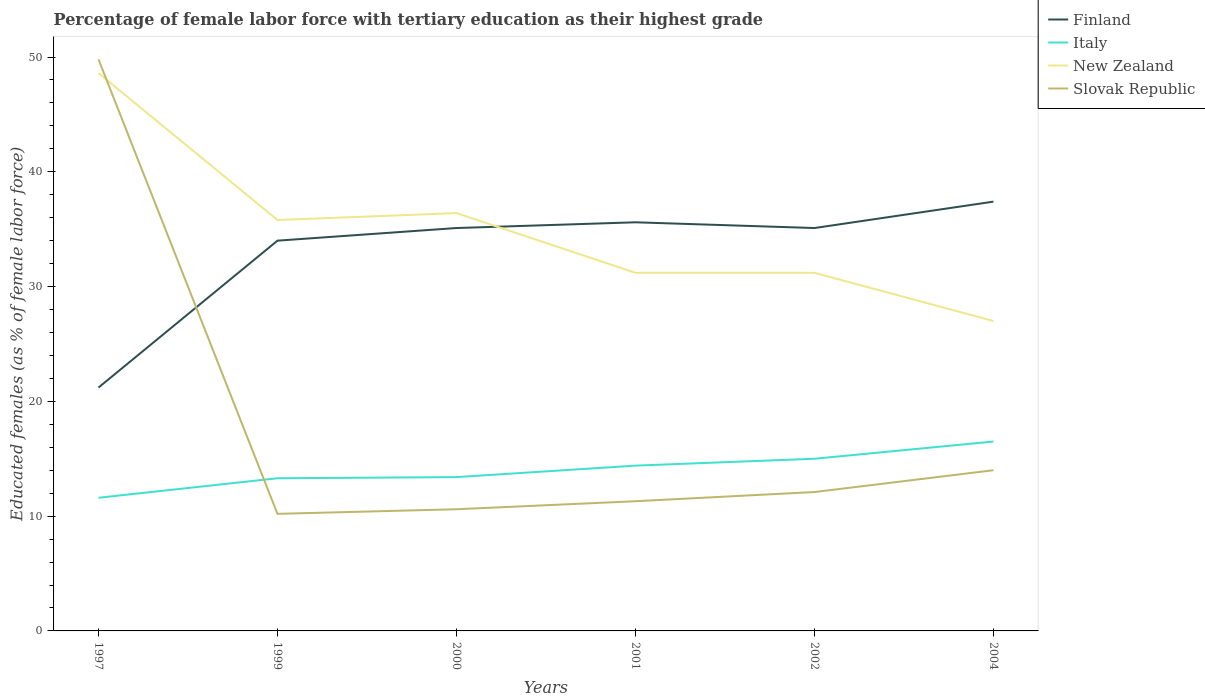Is the number of lines equal to the number of legend labels?
Ensure brevity in your answer.  Yes. What is the total percentage of female labor force with tertiary education in Italy in the graph?
Your answer should be very brief. -2.8. What is the difference between the highest and the second highest percentage of female labor force with tertiary education in New Zealand?
Provide a succinct answer. 21.6. Is the percentage of female labor force with tertiary education in New Zealand strictly greater than the percentage of female labor force with tertiary education in Finland over the years?
Provide a succinct answer. No. Are the values on the major ticks of Y-axis written in scientific E-notation?
Your answer should be very brief. No. Does the graph contain any zero values?
Provide a succinct answer. No. Does the graph contain grids?
Make the answer very short. No. What is the title of the graph?
Offer a terse response. Percentage of female labor force with tertiary education as their highest grade. What is the label or title of the Y-axis?
Your response must be concise. Educated females (as % of female labor force). What is the Educated females (as % of female labor force) in Finland in 1997?
Offer a terse response. 21.2. What is the Educated females (as % of female labor force) in Italy in 1997?
Provide a succinct answer. 11.6. What is the Educated females (as % of female labor force) in New Zealand in 1997?
Your response must be concise. 48.6. What is the Educated females (as % of female labor force) in Slovak Republic in 1997?
Make the answer very short. 49.8. What is the Educated females (as % of female labor force) in Finland in 1999?
Ensure brevity in your answer.  34. What is the Educated females (as % of female labor force) of Italy in 1999?
Give a very brief answer. 13.3. What is the Educated females (as % of female labor force) in New Zealand in 1999?
Offer a terse response. 35.8. What is the Educated females (as % of female labor force) in Slovak Republic in 1999?
Offer a very short reply. 10.2. What is the Educated females (as % of female labor force) of Finland in 2000?
Provide a short and direct response. 35.1. What is the Educated females (as % of female labor force) of Italy in 2000?
Keep it short and to the point. 13.4. What is the Educated females (as % of female labor force) of New Zealand in 2000?
Keep it short and to the point. 36.4. What is the Educated females (as % of female labor force) of Slovak Republic in 2000?
Your answer should be compact. 10.6. What is the Educated females (as % of female labor force) of Finland in 2001?
Offer a very short reply. 35.6. What is the Educated females (as % of female labor force) in Italy in 2001?
Make the answer very short. 14.4. What is the Educated females (as % of female labor force) in New Zealand in 2001?
Keep it short and to the point. 31.2. What is the Educated females (as % of female labor force) of Slovak Republic in 2001?
Your answer should be very brief. 11.3. What is the Educated females (as % of female labor force) in Finland in 2002?
Ensure brevity in your answer.  35.1. What is the Educated females (as % of female labor force) in New Zealand in 2002?
Give a very brief answer. 31.2. What is the Educated females (as % of female labor force) in Slovak Republic in 2002?
Offer a terse response. 12.1. What is the Educated females (as % of female labor force) of Finland in 2004?
Your answer should be compact. 37.4. What is the Educated females (as % of female labor force) of Italy in 2004?
Your answer should be compact. 16.5. What is the Educated females (as % of female labor force) of Slovak Republic in 2004?
Give a very brief answer. 14. Across all years, what is the maximum Educated females (as % of female labor force) of Finland?
Offer a terse response. 37.4. Across all years, what is the maximum Educated females (as % of female labor force) of Italy?
Your answer should be very brief. 16.5. Across all years, what is the maximum Educated females (as % of female labor force) of New Zealand?
Your answer should be very brief. 48.6. Across all years, what is the maximum Educated females (as % of female labor force) of Slovak Republic?
Give a very brief answer. 49.8. Across all years, what is the minimum Educated females (as % of female labor force) of Finland?
Provide a short and direct response. 21.2. Across all years, what is the minimum Educated females (as % of female labor force) of Italy?
Offer a very short reply. 11.6. Across all years, what is the minimum Educated females (as % of female labor force) in Slovak Republic?
Give a very brief answer. 10.2. What is the total Educated females (as % of female labor force) in Finland in the graph?
Offer a terse response. 198.4. What is the total Educated females (as % of female labor force) in Italy in the graph?
Give a very brief answer. 84.2. What is the total Educated females (as % of female labor force) in New Zealand in the graph?
Offer a very short reply. 210.2. What is the total Educated females (as % of female labor force) in Slovak Republic in the graph?
Your answer should be very brief. 108. What is the difference between the Educated females (as % of female labor force) in New Zealand in 1997 and that in 1999?
Ensure brevity in your answer.  12.8. What is the difference between the Educated females (as % of female labor force) in Slovak Republic in 1997 and that in 1999?
Offer a very short reply. 39.6. What is the difference between the Educated females (as % of female labor force) of Finland in 1997 and that in 2000?
Your response must be concise. -13.9. What is the difference between the Educated females (as % of female labor force) of Italy in 1997 and that in 2000?
Provide a succinct answer. -1.8. What is the difference between the Educated females (as % of female labor force) of Slovak Republic in 1997 and that in 2000?
Offer a terse response. 39.2. What is the difference between the Educated females (as % of female labor force) in Finland in 1997 and that in 2001?
Your answer should be very brief. -14.4. What is the difference between the Educated females (as % of female labor force) in Slovak Republic in 1997 and that in 2001?
Your response must be concise. 38.5. What is the difference between the Educated females (as % of female labor force) of Italy in 1997 and that in 2002?
Your response must be concise. -3.4. What is the difference between the Educated females (as % of female labor force) in New Zealand in 1997 and that in 2002?
Provide a succinct answer. 17.4. What is the difference between the Educated females (as % of female labor force) of Slovak Republic in 1997 and that in 2002?
Provide a short and direct response. 37.7. What is the difference between the Educated females (as % of female labor force) in Finland in 1997 and that in 2004?
Provide a short and direct response. -16.2. What is the difference between the Educated females (as % of female labor force) of New Zealand in 1997 and that in 2004?
Offer a very short reply. 21.6. What is the difference between the Educated females (as % of female labor force) of Slovak Republic in 1997 and that in 2004?
Give a very brief answer. 35.8. What is the difference between the Educated females (as % of female labor force) in Slovak Republic in 1999 and that in 2000?
Your answer should be very brief. -0.4. What is the difference between the Educated females (as % of female labor force) of New Zealand in 1999 and that in 2001?
Your response must be concise. 4.6. What is the difference between the Educated females (as % of female labor force) in Slovak Republic in 1999 and that in 2001?
Your answer should be compact. -1.1. What is the difference between the Educated females (as % of female labor force) in Finland in 1999 and that in 2002?
Ensure brevity in your answer.  -1.1. What is the difference between the Educated females (as % of female labor force) of Italy in 1999 and that in 2004?
Provide a short and direct response. -3.2. What is the difference between the Educated females (as % of female labor force) in Slovak Republic in 1999 and that in 2004?
Your answer should be very brief. -3.8. What is the difference between the Educated females (as % of female labor force) of Finland in 2000 and that in 2001?
Your answer should be very brief. -0.5. What is the difference between the Educated females (as % of female labor force) of New Zealand in 2000 and that in 2001?
Your answer should be very brief. 5.2. What is the difference between the Educated females (as % of female labor force) of Slovak Republic in 2000 and that in 2001?
Provide a short and direct response. -0.7. What is the difference between the Educated females (as % of female labor force) in Slovak Republic in 2000 and that in 2004?
Offer a terse response. -3.4. What is the difference between the Educated females (as % of female labor force) in Finland in 2001 and that in 2002?
Your answer should be compact. 0.5. What is the difference between the Educated females (as % of female labor force) in New Zealand in 2001 and that in 2002?
Your answer should be compact. 0. What is the difference between the Educated females (as % of female labor force) in Italy in 2001 and that in 2004?
Your answer should be very brief. -2.1. What is the difference between the Educated females (as % of female labor force) of New Zealand in 2001 and that in 2004?
Offer a terse response. 4.2. What is the difference between the Educated females (as % of female labor force) in Slovak Republic in 2001 and that in 2004?
Give a very brief answer. -2.7. What is the difference between the Educated females (as % of female labor force) in Finland in 2002 and that in 2004?
Provide a succinct answer. -2.3. What is the difference between the Educated females (as % of female labor force) of New Zealand in 2002 and that in 2004?
Provide a succinct answer. 4.2. What is the difference between the Educated females (as % of female labor force) in Slovak Republic in 2002 and that in 2004?
Your answer should be very brief. -1.9. What is the difference between the Educated females (as % of female labor force) of Finland in 1997 and the Educated females (as % of female labor force) of Italy in 1999?
Provide a succinct answer. 7.9. What is the difference between the Educated females (as % of female labor force) in Finland in 1997 and the Educated females (as % of female labor force) in New Zealand in 1999?
Your response must be concise. -14.6. What is the difference between the Educated females (as % of female labor force) in Italy in 1997 and the Educated females (as % of female labor force) in New Zealand in 1999?
Offer a very short reply. -24.2. What is the difference between the Educated females (as % of female labor force) in New Zealand in 1997 and the Educated females (as % of female labor force) in Slovak Republic in 1999?
Give a very brief answer. 38.4. What is the difference between the Educated females (as % of female labor force) of Finland in 1997 and the Educated females (as % of female labor force) of New Zealand in 2000?
Provide a succinct answer. -15.2. What is the difference between the Educated females (as % of female labor force) of Finland in 1997 and the Educated females (as % of female labor force) of Slovak Republic in 2000?
Offer a terse response. 10.6. What is the difference between the Educated females (as % of female labor force) of Italy in 1997 and the Educated females (as % of female labor force) of New Zealand in 2000?
Offer a very short reply. -24.8. What is the difference between the Educated females (as % of female labor force) in New Zealand in 1997 and the Educated females (as % of female labor force) in Slovak Republic in 2000?
Offer a terse response. 38. What is the difference between the Educated females (as % of female labor force) of Finland in 1997 and the Educated females (as % of female labor force) of New Zealand in 2001?
Offer a very short reply. -10. What is the difference between the Educated females (as % of female labor force) in Finland in 1997 and the Educated females (as % of female labor force) in Slovak Republic in 2001?
Make the answer very short. 9.9. What is the difference between the Educated females (as % of female labor force) of Italy in 1997 and the Educated females (as % of female labor force) of New Zealand in 2001?
Make the answer very short. -19.6. What is the difference between the Educated females (as % of female labor force) of Italy in 1997 and the Educated females (as % of female labor force) of Slovak Republic in 2001?
Give a very brief answer. 0.3. What is the difference between the Educated females (as % of female labor force) in New Zealand in 1997 and the Educated females (as % of female labor force) in Slovak Republic in 2001?
Offer a very short reply. 37.3. What is the difference between the Educated females (as % of female labor force) of Finland in 1997 and the Educated females (as % of female labor force) of New Zealand in 2002?
Provide a succinct answer. -10. What is the difference between the Educated females (as % of female labor force) of Italy in 1997 and the Educated females (as % of female labor force) of New Zealand in 2002?
Your answer should be very brief. -19.6. What is the difference between the Educated females (as % of female labor force) in Italy in 1997 and the Educated females (as % of female labor force) in Slovak Republic in 2002?
Provide a short and direct response. -0.5. What is the difference between the Educated females (as % of female labor force) of New Zealand in 1997 and the Educated females (as % of female labor force) of Slovak Republic in 2002?
Your answer should be compact. 36.5. What is the difference between the Educated females (as % of female labor force) of Finland in 1997 and the Educated females (as % of female labor force) of New Zealand in 2004?
Keep it short and to the point. -5.8. What is the difference between the Educated females (as % of female labor force) of Italy in 1997 and the Educated females (as % of female labor force) of New Zealand in 2004?
Your answer should be very brief. -15.4. What is the difference between the Educated females (as % of female labor force) in New Zealand in 1997 and the Educated females (as % of female labor force) in Slovak Republic in 2004?
Offer a terse response. 34.6. What is the difference between the Educated females (as % of female labor force) of Finland in 1999 and the Educated females (as % of female labor force) of Italy in 2000?
Your response must be concise. 20.6. What is the difference between the Educated females (as % of female labor force) in Finland in 1999 and the Educated females (as % of female labor force) in New Zealand in 2000?
Offer a terse response. -2.4. What is the difference between the Educated females (as % of female labor force) of Finland in 1999 and the Educated females (as % of female labor force) of Slovak Republic in 2000?
Make the answer very short. 23.4. What is the difference between the Educated females (as % of female labor force) of Italy in 1999 and the Educated females (as % of female labor force) of New Zealand in 2000?
Your answer should be very brief. -23.1. What is the difference between the Educated females (as % of female labor force) in New Zealand in 1999 and the Educated females (as % of female labor force) in Slovak Republic in 2000?
Provide a short and direct response. 25.2. What is the difference between the Educated females (as % of female labor force) in Finland in 1999 and the Educated females (as % of female labor force) in Italy in 2001?
Give a very brief answer. 19.6. What is the difference between the Educated females (as % of female labor force) of Finland in 1999 and the Educated females (as % of female labor force) of Slovak Republic in 2001?
Your answer should be compact. 22.7. What is the difference between the Educated females (as % of female labor force) of Italy in 1999 and the Educated females (as % of female labor force) of New Zealand in 2001?
Make the answer very short. -17.9. What is the difference between the Educated females (as % of female labor force) in New Zealand in 1999 and the Educated females (as % of female labor force) in Slovak Republic in 2001?
Make the answer very short. 24.5. What is the difference between the Educated females (as % of female labor force) in Finland in 1999 and the Educated females (as % of female labor force) in Slovak Republic in 2002?
Offer a very short reply. 21.9. What is the difference between the Educated females (as % of female labor force) in Italy in 1999 and the Educated females (as % of female labor force) in New Zealand in 2002?
Your answer should be very brief. -17.9. What is the difference between the Educated females (as % of female labor force) in New Zealand in 1999 and the Educated females (as % of female labor force) in Slovak Republic in 2002?
Give a very brief answer. 23.7. What is the difference between the Educated females (as % of female labor force) of Finland in 1999 and the Educated females (as % of female labor force) of Slovak Republic in 2004?
Ensure brevity in your answer.  20. What is the difference between the Educated females (as % of female labor force) in Italy in 1999 and the Educated females (as % of female labor force) in New Zealand in 2004?
Keep it short and to the point. -13.7. What is the difference between the Educated females (as % of female labor force) in Italy in 1999 and the Educated females (as % of female labor force) in Slovak Republic in 2004?
Provide a succinct answer. -0.7. What is the difference between the Educated females (as % of female labor force) in New Zealand in 1999 and the Educated females (as % of female labor force) in Slovak Republic in 2004?
Keep it short and to the point. 21.8. What is the difference between the Educated females (as % of female labor force) of Finland in 2000 and the Educated females (as % of female labor force) of Italy in 2001?
Provide a short and direct response. 20.7. What is the difference between the Educated females (as % of female labor force) in Finland in 2000 and the Educated females (as % of female labor force) in Slovak Republic in 2001?
Give a very brief answer. 23.8. What is the difference between the Educated females (as % of female labor force) of Italy in 2000 and the Educated females (as % of female labor force) of New Zealand in 2001?
Keep it short and to the point. -17.8. What is the difference between the Educated females (as % of female labor force) of New Zealand in 2000 and the Educated females (as % of female labor force) of Slovak Republic in 2001?
Offer a very short reply. 25.1. What is the difference between the Educated females (as % of female labor force) in Finland in 2000 and the Educated females (as % of female labor force) in Italy in 2002?
Your answer should be compact. 20.1. What is the difference between the Educated females (as % of female labor force) in Italy in 2000 and the Educated females (as % of female labor force) in New Zealand in 2002?
Offer a very short reply. -17.8. What is the difference between the Educated females (as % of female labor force) in New Zealand in 2000 and the Educated females (as % of female labor force) in Slovak Republic in 2002?
Give a very brief answer. 24.3. What is the difference between the Educated females (as % of female labor force) of Finland in 2000 and the Educated females (as % of female labor force) of Slovak Republic in 2004?
Your answer should be compact. 21.1. What is the difference between the Educated females (as % of female labor force) in Italy in 2000 and the Educated females (as % of female labor force) in New Zealand in 2004?
Provide a short and direct response. -13.6. What is the difference between the Educated females (as % of female labor force) of Italy in 2000 and the Educated females (as % of female labor force) of Slovak Republic in 2004?
Offer a very short reply. -0.6. What is the difference between the Educated females (as % of female labor force) in New Zealand in 2000 and the Educated females (as % of female labor force) in Slovak Republic in 2004?
Give a very brief answer. 22.4. What is the difference between the Educated females (as % of female labor force) in Finland in 2001 and the Educated females (as % of female labor force) in Italy in 2002?
Give a very brief answer. 20.6. What is the difference between the Educated females (as % of female labor force) in Finland in 2001 and the Educated females (as % of female labor force) in New Zealand in 2002?
Ensure brevity in your answer.  4.4. What is the difference between the Educated females (as % of female labor force) in Finland in 2001 and the Educated females (as % of female labor force) in Slovak Republic in 2002?
Make the answer very short. 23.5. What is the difference between the Educated females (as % of female labor force) of Italy in 2001 and the Educated females (as % of female labor force) of New Zealand in 2002?
Your answer should be compact. -16.8. What is the difference between the Educated females (as % of female labor force) in Italy in 2001 and the Educated females (as % of female labor force) in Slovak Republic in 2002?
Give a very brief answer. 2.3. What is the difference between the Educated females (as % of female labor force) in New Zealand in 2001 and the Educated females (as % of female labor force) in Slovak Republic in 2002?
Your response must be concise. 19.1. What is the difference between the Educated females (as % of female labor force) of Finland in 2001 and the Educated females (as % of female labor force) of Italy in 2004?
Provide a succinct answer. 19.1. What is the difference between the Educated females (as % of female labor force) in Finland in 2001 and the Educated females (as % of female labor force) in New Zealand in 2004?
Your answer should be very brief. 8.6. What is the difference between the Educated females (as % of female labor force) in Finland in 2001 and the Educated females (as % of female labor force) in Slovak Republic in 2004?
Give a very brief answer. 21.6. What is the difference between the Educated females (as % of female labor force) of Finland in 2002 and the Educated females (as % of female labor force) of New Zealand in 2004?
Ensure brevity in your answer.  8.1. What is the difference between the Educated females (as % of female labor force) of Finland in 2002 and the Educated females (as % of female labor force) of Slovak Republic in 2004?
Make the answer very short. 21.1. What is the difference between the Educated females (as % of female labor force) of New Zealand in 2002 and the Educated females (as % of female labor force) of Slovak Republic in 2004?
Offer a very short reply. 17.2. What is the average Educated females (as % of female labor force) in Finland per year?
Ensure brevity in your answer.  33.07. What is the average Educated females (as % of female labor force) of Italy per year?
Give a very brief answer. 14.03. What is the average Educated females (as % of female labor force) of New Zealand per year?
Provide a succinct answer. 35.03. In the year 1997, what is the difference between the Educated females (as % of female labor force) in Finland and Educated females (as % of female labor force) in Italy?
Keep it short and to the point. 9.6. In the year 1997, what is the difference between the Educated females (as % of female labor force) of Finland and Educated females (as % of female labor force) of New Zealand?
Offer a very short reply. -27.4. In the year 1997, what is the difference between the Educated females (as % of female labor force) in Finland and Educated females (as % of female labor force) in Slovak Republic?
Keep it short and to the point. -28.6. In the year 1997, what is the difference between the Educated females (as % of female labor force) in Italy and Educated females (as % of female labor force) in New Zealand?
Offer a very short reply. -37. In the year 1997, what is the difference between the Educated females (as % of female labor force) in Italy and Educated females (as % of female labor force) in Slovak Republic?
Your response must be concise. -38.2. In the year 1997, what is the difference between the Educated females (as % of female labor force) of New Zealand and Educated females (as % of female labor force) of Slovak Republic?
Your answer should be compact. -1.2. In the year 1999, what is the difference between the Educated females (as % of female labor force) of Finland and Educated females (as % of female labor force) of Italy?
Your response must be concise. 20.7. In the year 1999, what is the difference between the Educated females (as % of female labor force) of Finland and Educated females (as % of female labor force) of Slovak Republic?
Offer a terse response. 23.8. In the year 1999, what is the difference between the Educated females (as % of female labor force) of Italy and Educated females (as % of female labor force) of New Zealand?
Your answer should be compact. -22.5. In the year 1999, what is the difference between the Educated females (as % of female labor force) of New Zealand and Educated females (as % of female labor force) of Slovak Republic?
Your answer should be very brief. 25.6. In the year 2000, what is the difference between the Educated females (as % of female labor force) in Finland and Educated females (as % of female labor force) in Italy?
Offer a terse response. 21.7. In the year 2000, what is the difference between the Educated females (as % of female labor force) of Finland and Educated females (as % of female labor force) of New Zealand?
Your answer should be very brief. -1.3. In the year 2000, what is the difference between the Educated females (as % of female labor force) of Finland and Educated females (as % of female labor force) of Slovak Republic?
Make the answer very short. 24.5. In the year 2000, what is the difference between the Educated females (as % of female labor force) in New Zealand and Educated females (as % of female labor force) in Slovak Republic?
Make the answer very short. 25.8. In the year 2001, what is the difference between the Educated females (as % of female labor force) in Finland and Educated females (as % of female labor force) in Italy?
Provide a succinct answer. 21.2. In the year 2001, what is the difference between the Educated females (as % of female labor force) in Finland and Educated females (as % of female labor force) in New Zealand?
Ensure brevity in your answer.  4.4. In the year 2001, what is the difference between the Educated females (as % of female labor force) of Finland and Educated females (as % of female labor force) of Slovak Republic?
Offer a terse response. 24.3. In the year 2001, what is the difference between the Educated females (as % of female labor force) of Italy and Educated females (as % of female labor force) of New Zealand?
Give a very brief answer. -16.8. In the year 2001, what is the difference between the Educated females (as % of female labor force) in Italy and Educated females (as % of female labor force) in Slovak Republic?
Ensure brevity in your answer.  3.1. In the year 2001, what is the difference between the Educated females (as % of female labor force) of New Zealand and Educated females (as % of female labor force) of Slovak Republic?
Your answer should be compact. 19.9. In the year 2002, what is the difference between the Educated females (as % of female labor force) in Finland and Educated females (as % of female labor force) in Italy?
Ensure brevity in your answer.  20.1. In the year 2002, what is the difference between the Educated females (as % of female labor force) of Finland and Educated females (as % of female labor force) of New Zealand?
Provide a short and direct response. 3.9. In the year 2002, what is the difference between the Educated females (as % of female labor force) of Italy and Educated females (as % of female labor force) of New Zealand?
Give a very brief answer. -16.2. In the year 2002, what is the difference between the Educated females (as % of female labor force) in New Zealand and Educated females (as % of female labor force) in Slovak Republic?
Make the answer very short. 19.1. In the year 2004, what is the difference between the Educated females (as % of female labor force) of Finland and Educated females (as % of female labor force) of Italy?
Offer a very short reply. 20.9. In the year 2004, what is the difference between the Educated females (as % of female labor force) in Finland and Educated females (as % of female labor force) in New Zealand?
Make the answer very short. 10.4. In the year 2004, what is the difference between the Educated females (as % of female labor force) of Finland and Educated females (as % of female labor force) of Slovak Republic?
Offer a very short reply. 23.4. In the year 2004, what is the difference between the Educated females (as % of female labor force) in Italy and Educated females (as % of female labor force) in New Zealand?
Ensure brevity in your answer.  -10.5. In the year 2004, what is the difference between the Educated females (as % of female labor force) in New Zealand and Educated females (as % of female labor force) in Slovak Republic?
Your answer should be very brief. 13. What is the ratio of the Educated females (as % of female labor force) in Finland in 1997 to that in 1999?
Give a very brief answer. 0.62. What is the ratio of the Educated females (as % of female labor force) in Italy in 1997 to that in 1999?
Your answer should be compact. 0.87. What is the ratio of the Educated females (as % of female labor force) of New Zealand in 1997 to that in 1999?
Your response must be concise. 1.36. What is the ratio of the Educated females (as % of female labor force) of Slovak Republic in 1997 to that in 1999?
Provide a short and direct response. 4.88. What is the ratio of the Educated females (as % of female labor force) of Finland in 1997 to that in 2000?
Provide a succinct answer. 0.6. What is the ratio of the Educated females (as % of female labor force) of Italy in 1997 to that in 2000?
Provide a short and direct response. 0.87. What is the ratio of the Educated females (as % of female labor force) of New Zealand in 1997 to that in 2000?
Your answer should be compact. 1.34. What is the ratio of the Educated females (as % of female labor force) in Slovak Republic in 1997 to that in 2000?
Your answer should be very brief. 4.7. What is the ratio of the Educated females (as % of female labor force) in Finland in 1997 to that in 2001?
Give a very brief answer. 0.6. What is the ratio of the Educated females (as % of female labor force) of Italy in 1997 to that in 2001?
Provide a succinct answer. 0.81. What is the ratio of the Educated females (as % of female labor force) of New Zealand in 1997 to that in 2001?
Provide a succinct answer. 1.56. What is the ratio of the Educated females (as % of female labor force) of Slovak Republic in 1997 to that in 2001?
Give a very brief answer. 4.41. What is the ratio of the Educated females (as % of female labor force) in Finland in 1997 to that in 2002?
Give a very brief answer. 0.6. What is the ratio of the Educated females (as % of female labor force) of Italy in 1997 to that in 2002?
Your response must be concise. 0.77. What is the ratio of the Educated females (as % of female labor force) of New Zealand in 1997 to that in 2002?
Your response must be concise. 1.56. What is the ratio of the Educated females (as % of female labor force) of Slovak Republic in 1997 to that in 2002?
Your answer should be very brief. 4.12. What is the ratio of the Educated females (as % of female labor force) of Finland in 1997 to that in 2004?
Give a very brief answer. 0.57. What is the ratio of the Educated females (as % of female labor force) of Italy in 1997 to that in 2004?
Provide a short and direct response. 0.7. What is the ratio of the Educated females (as % of female labor force) in Slovak Republic in 1997 to that in 2004?
Ensure brevity in your answer.  3.56. What is the ratio of the Educated females (as % of female labor force) of Finland in 1999 to that in 2000?
Ensure brevity in your answer.  0.97. What is the ratio of the Educated females (as % of female labor force) in New Zealand in 1999 to that in 2000?
Offer a terse response. 0.98. What is the ratio of the Educated females (as % of female labor force) of Slovak Republic in 1999 to that in 2000?
Your response must be concise. 0.96. What is the ratio of the Educated females (as % of female labor force) of Finland in 1999 to that in 2001?
Ensure brevity in your answer.  0.96. What is the ratio of the Educated females (as % of female labor force) of Italy in 1999 to that in 2001?
Your answer should be compact. 0.92. What is the ratio of the Educated females (as % of female labor force) in New Zealand in 1999 to that in 2001?
Ensure brevity in your answer.  1.15. What is the ratio of the Educated females (as % of female labor force) in Slovak Republic in 1999 to that in 2001?
Keep it short and to the point. 0.9. What is the ratio of the Educated females (as % of female labor force) in Finland in 1999 to that in 2002?
Ensure brevity in your answer.  0.97. What is the ratio of the Educated females (as % of female labor force) in Italy in 1999 to that in 2002?
Offer a very short reply. 0.89. What is the ratio of the Educated females (as % of female labor force) in New Zealand in 1999 to that in 2002?
Keep it short and to the point. 1.15. What is the ratio of the Educated females (as % of female labor force) of Slovak Republic in 1999 to that in 2002?
Offer a terse response. 0.84. What is the ratio of the Educated females (as % of female labor force) of Italy in 1999 to that in 2004?
Provide a succinct answer. 0.81. What is the ratio of the Educated females (as % of female labor force) of New Zealand in 1999 to that in 2004?
Ensure brevity in your answer.  1.33. What is the ratio of the Educated females (as % of female labor force) in Slovak Republic in 1999 to that in 2004?
Offer a terse response. 0.73. What is the ratio of the Educated females (as % of female labor force) of Italy in 2000 to that in 2001?
Your answer should be very brief. 0.93. What is the ratio of the Educated females (as % of female labor force) of Slovak Republic in 2000 to that in 2001?
Give a very brief answer. 0.94. What is the ratio of the Educated females (as % of female labor force) of Finland in 2000 to that in 2002?
Ensure brevity in your answer.  1. What is the ratio of the Educated females (as % of female labor force) of Italy in 2000 to that in 2002?
Your answer should be very brief. 0.89. What is the ratio of the Educated females (as % of female labor force) of New Zealand in 2000 to that in 2002?
Provide a succinct answer. 1.17. What is the ratio of the Educated females (as % of female labor force) in Slovak Republic in 2000 to that in 2002?
Keep it short and to the point. 0.88. What is the ratio of the Educated females (as % of female labor force) in Finland in 2000 to that in 2004?
Make the answer very short. 0.94. What is the ratio of the Educated females (as % of female labor force) in Italy in 2000 to that in 2004?
Ensure brevity in your answer.  0.81. What is the ratio of the Educated females (as % of female labor force) in New Zealand in 2000 to that in 2004?
Your answer should be compact. 1.35. What is the ratio of the Educated females (as % of female labor force) of Slovak Republic in 2000 to that in 2004?
Give a very brief answer. 0.76. What is the ratio of the Educated females (as % of female labor force) of Finland in 2001 to that in 2002?
Make the answer very short. 1.01. What is the ratio of the Educated females (as % of female labor force) in Italy in 2001 to that in 2002?
Your answer should be very brief. 0.96. What is the ratio of the Educated females (as % of female labor force) in New Zealand in 2001 to that in 2002?
Ensure brevity in your answer.  1. What is the ratio of the Educated females (as % of female labor force) of Slovak Republic in 2001 to that in 2002?
Ensure brevity in your answer.  0.93. What is the ratio of the Educated females (as % of female labor force) in Finland in 2001 to that in 2004?
Your answer should be very brief. 0.95. What is the ratio of the Educated females (as % of female labor force) in Italy in 2001 to that in 2004?
Ensure brevity in your answer.  0.87. What is the ratio of the Educated females (as % of female labor force) of New Zealand in 2001 to that in 2004?
Give a very brief answer. 1.16. What is the ratio of the Educated females (as % of female labor force) of Slovak Republic in 2001 to that in 2004?
Provide a short and direct response. 0.81. What is the ratio of the Educated females (as % of female labor force) of Finland in 2002 to that in 2004?
Your answer should be very brief. 0.94. What is the ratio of the Educated females (as % of female labor force) in New Zealand in 2002 to that in 2004?
Give a very brief answer. 1.16. What is the ratio of the Educated females (as % of female labor force) in Slovak Republic in 2002 to that in 2004?
Offer a very short reply. 0.86. What is the difference between the highest and the second highest Educated females (as % of female labor force) of Finland?
Your answer should be very brief. 1.8. What is the difference between the highest and the second highest Educated females (as % of female labor force) in Italy?
Make the answer very short. 1.5. What is the difference between the highest and the second highest Educated females (as % of female labor force) in New Zealand?
Your answer should be compact. 12.2. What is the difference between the highest and the second highest Educated females (as % of female labor force) of Slovak Republic?
Make the answer very short. 35.8. What is the difference between the highest and the lowest Educated females (as % of female labor force) in Finland?
Keep it short and to the point. 16.2. What is the difference between the highest and the lowest Educated females (as % of female labor force) of New Zealand?
Offer a terse response. 21.6. What is the difference between the highest and the lowest Educated females (as % of female labor force) in Slovak Republic?
Your answer should be very brief. 39.6. 